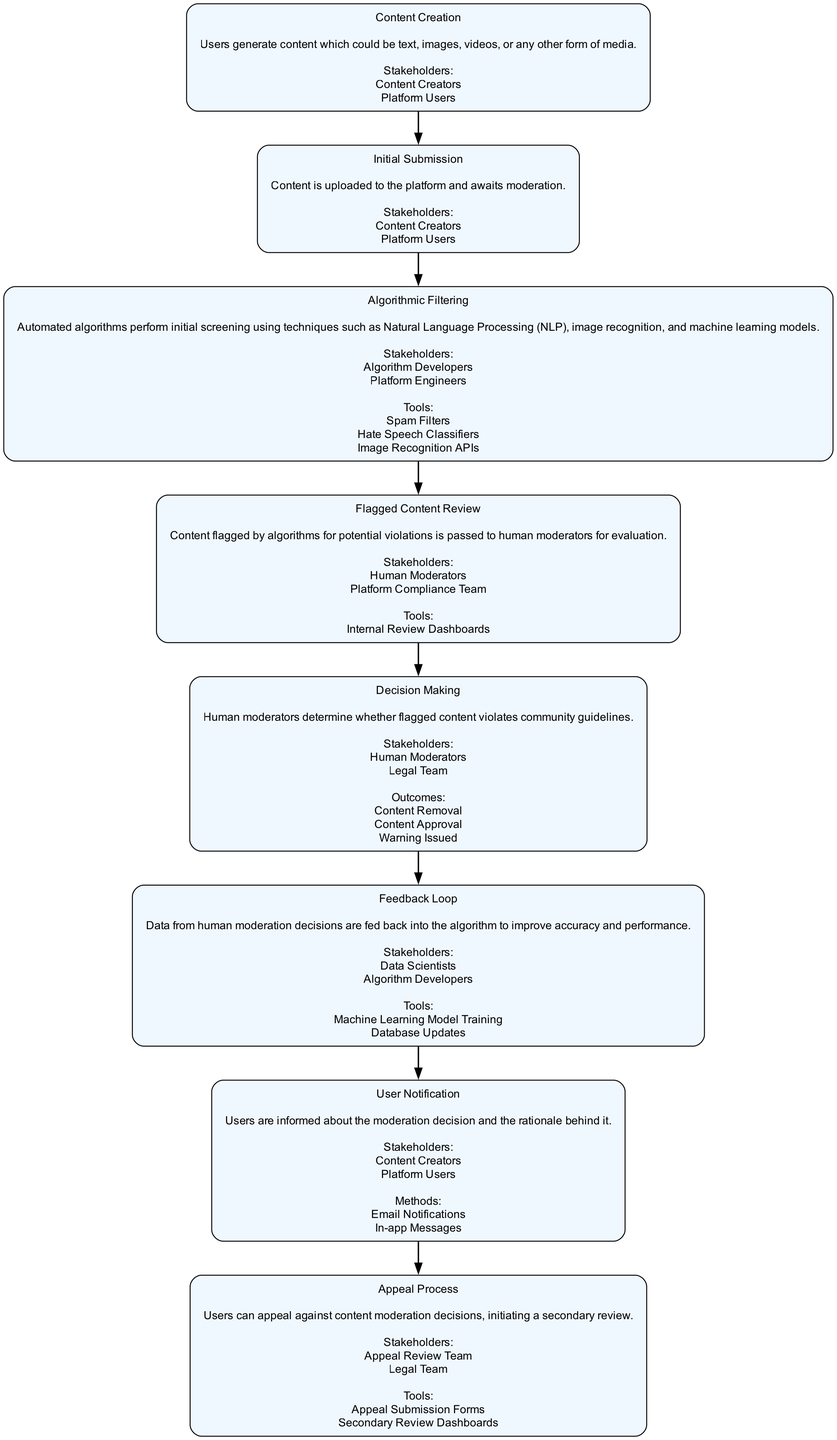What is the first stage in the content moderation pathway? The first stage is "Content Creation," which indicates the starting point where users generate various types of content.
Answer: Content Creation How many stakeholders are involved in the "Feedback Loop" stage? The "Feedback Loop" stage lists two stakeholders: Data Scientists and Algorithm Developers. Count these to arrive at the total.
Answer: 2 What is the outcome of the "Decision Making" stage? The "Decision Making" stage has three possible outcomes: Content Removal, Content Approval, and Warning Issued. These outcomes are decisive actions taken as the result of human moderation.
Answer: Content Removal, Content Approval, Warning Issued What is the tool used in the "Flagged Content Review"? In the "Flagged Content Review" stage, the tool specified is "Internal Review Dashboards," which assists human moderators in evaluating flagged content.
Answer: Internal Review Dashboards Which stage indicates user interaction after moderation decisions? The stage where users are informed about moderation decisions and their rationales falls under "User Notification," as it deals directly with user engagement following a decision.
Answer: User Notification Which stakeholders are involved in the "Appeal Process"? The "Appeal Process" stage includes two stakeholders: the Appeal Review Team and the Legal Team, who are responsible for reviewing disputed moderation decisions.
Answer: Appeal Review Team, Legal Team Which stage comes directly after "Algorithmic Filtering"? Following the "Algorithmic Filtering," the "Flagged Content Review" stage occurs, where human moderators evaluate the content flagged by automated algorithms.
Answer: Flagged Content Review How many total stages are present in the clinical pathway? By counting each stage listed in the provided data, we find there are eight distinct stages in the clinical pathway.
Answer: 8 